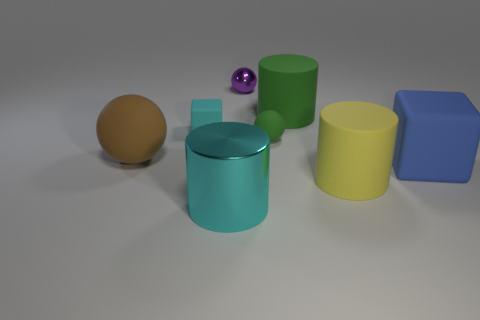Is there a small purple metal object to the left of the sphere on the left side of the large cylinder left of the purple metallic ball?
Give a very brief answer. No. Are there any small purple spheres in front of the blue thing?
Keep it short and to the point. No. How many tiny spheres have the same color as the shiny cylinder?
Offer a very short reply. 0. What size is the blue object that is the same material as the small green thing?
Your answer should be compact. Large. There is a green object in front of the rubber block left of the big rubber object that is right of the yellow thing; what size is it?
Give a very brief answer. Small. There is a rubber block to the left of the green sphere; what is its size?
Give a very brief answer. Small. How many gray things are large matte blocks or big matte spheres?
Your answer should be compact. 0. Are there any green metallic balls of the same size as the blue matte cube?
Make the answer very short. No. What material is the cyan cylinder that is the same size as the green cylinder?
Make the answer very short. Metal. Does the rubber thing that is in front of the blue cube have the same size as the block to the left of the small purple ball?
Provide a short and direct response. No. 